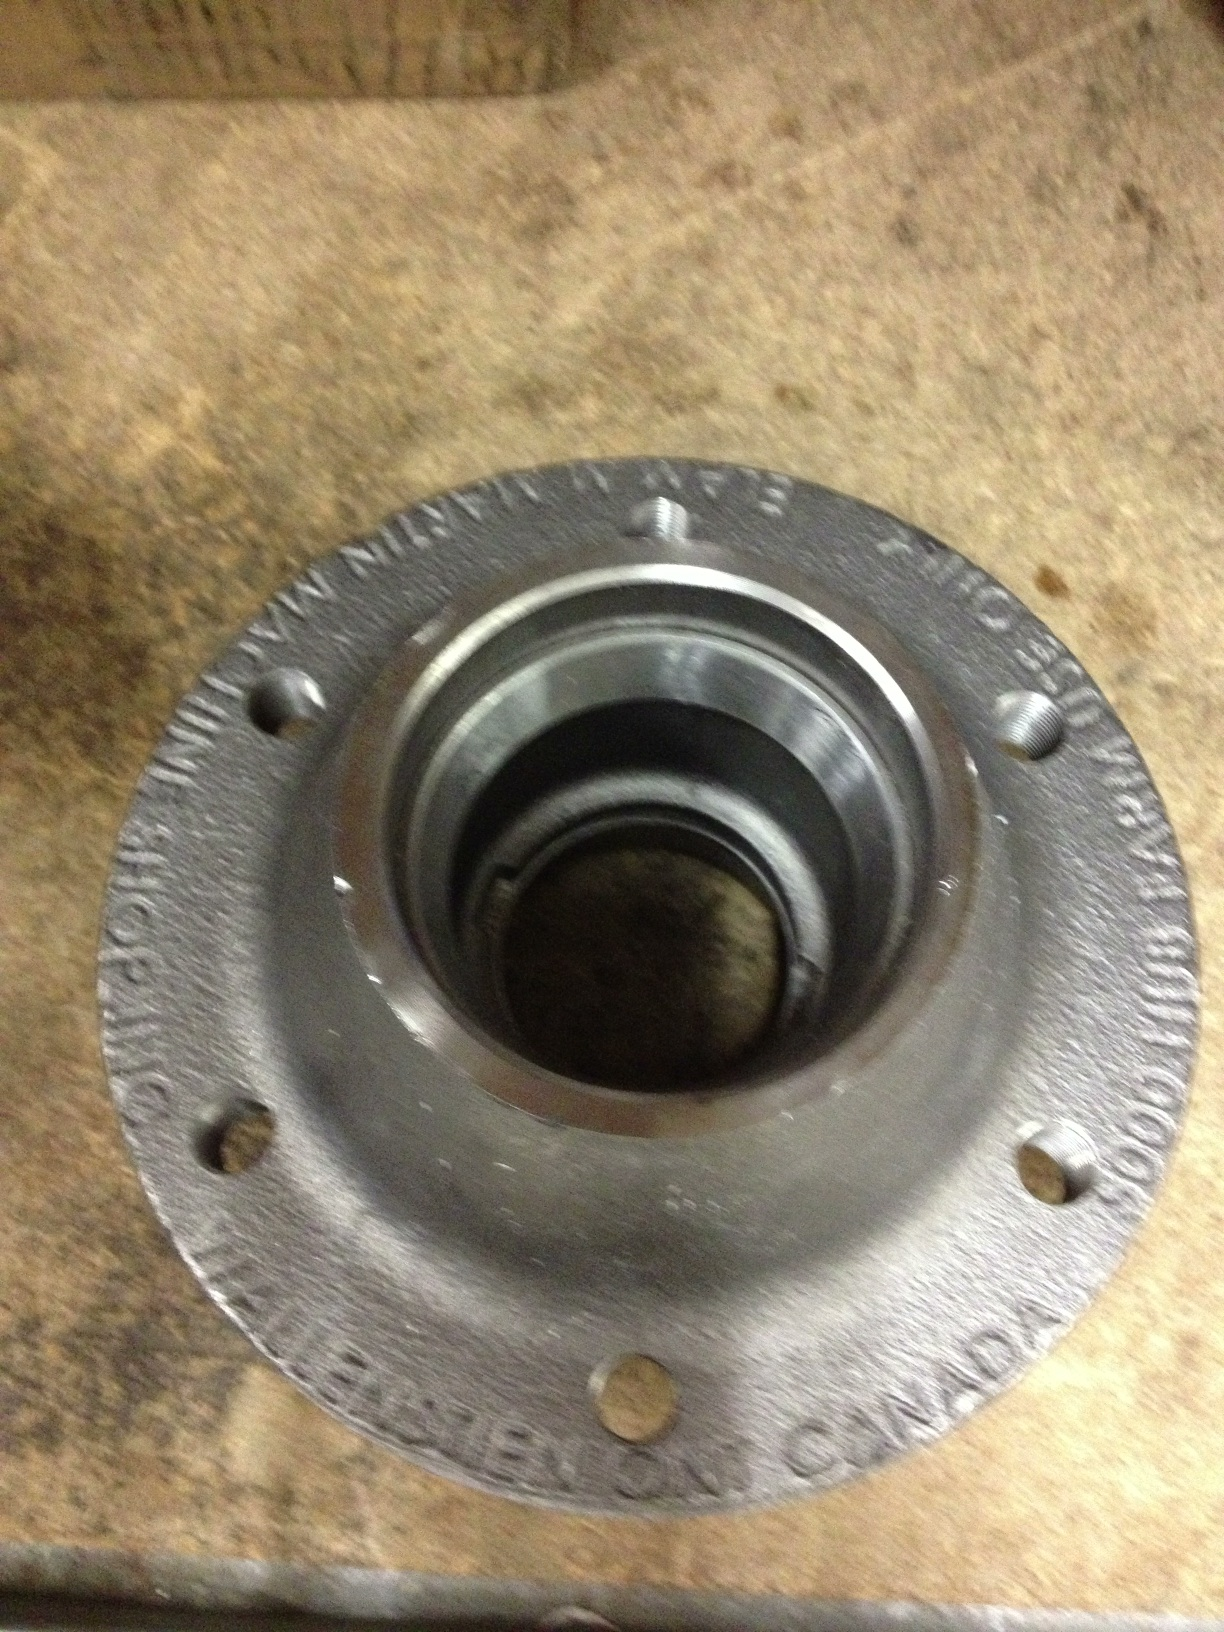Can you describe a realistic scenario where the condition of the wheel hub is extremely critical? A realistic scenario where the condition of the wheel hub is extremely critical is during long-distance trucking. The wheel hubs must endure prolonged periods of high-speed driving while bearing heavy loads. Any failure in these components could lead to catastrophic consequences, like a wheel detachment at highway speeds, posing severe risks to the driver and other road users. Regular maintenance and inspections are crucial in such scenarios to ensure the wheel hubs are in optimal condition and can safely support the weight and stresses encountered during long hauls. What might a day in the life of a wheel hub look like during a long-distance truck haul? In a long-distance truck haul, the wheel hub would experience a demanding and varied day. Starting early in the morning, it supports the truck’s frame as heavy cargo is loaded, immediately coming under significant stress. As the journey begins, it endures hours of high-speed rotation, with bearings constantly mitigating friction. It passes through different terrains, from smooth highways to bumpy country roads, each jostling and testing its durability. Throughout the day, it must cope with varying weather conditions – from scorching heat that expands the metal to cold that contracts it, potentially causing micro-cracks. Maintaining its integrity, the hub ensures the trucker can rely on a safe and smooth ride. By evening, upon reaching the destination, the hub bears the final step of unloading, possibly heating up due to prolonged use. Maintaining optimal performance despite these challenges showcases the critical nature of the wheel hub in heavy-duty applications, emphasizing the importance of its engineering and regular maintenance. 